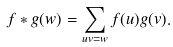Convert formula to latex. <formula><loc_0><loc_0><loc_500><loc_500>f \ast g ( w ) = \sum _ { u v = w } f ( u ) g ( v ) .</formula> 